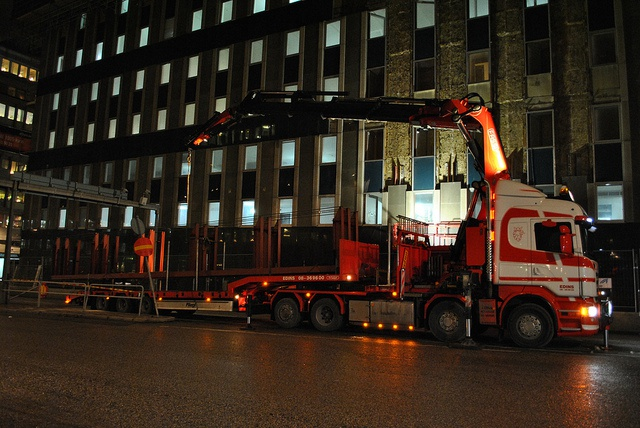Describe the objects in this image and their specific colors. I can see a truck in black, maroon, and gray tones in this image. 